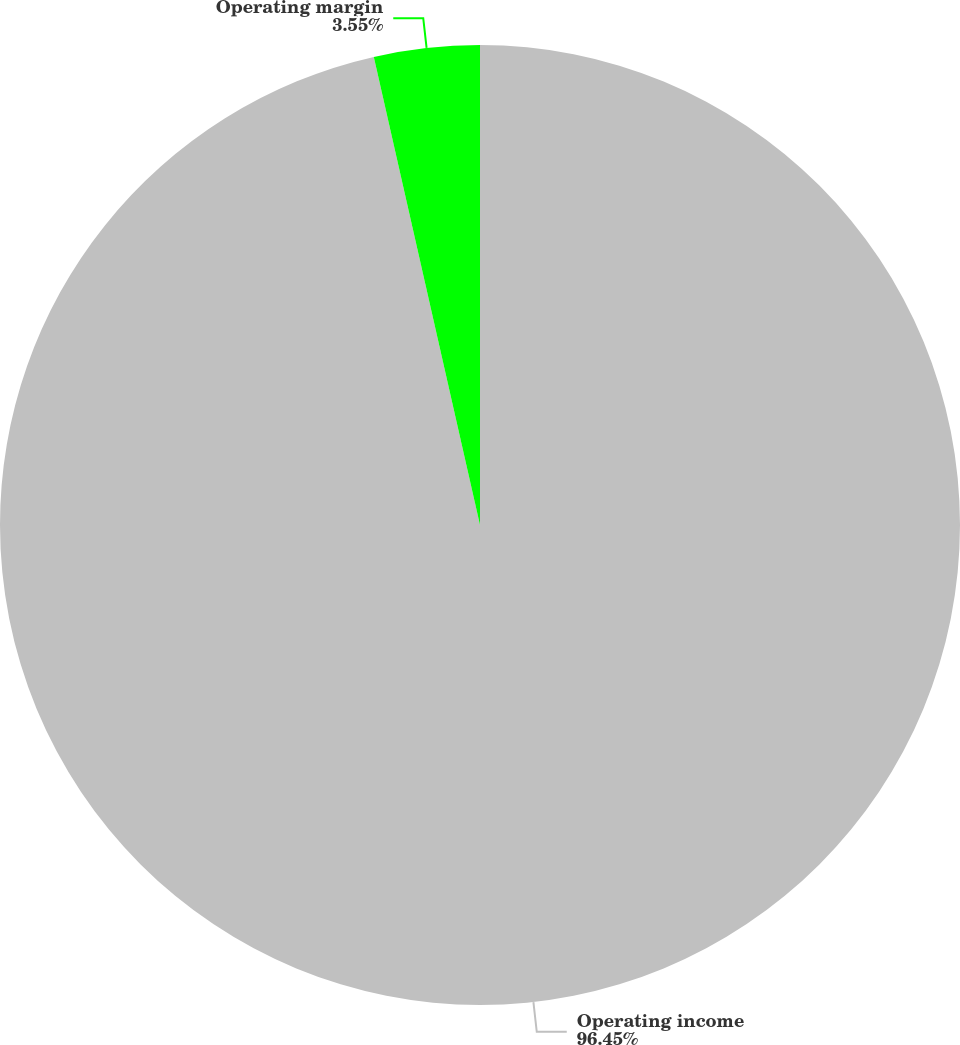Convert chart to OTSL. <chart><loc_0><loc_0><loc_500><loc_500><pie_chart><fcel>Operating income<fcel>Operating margin<nl><fcel>96.45%<fcel>3.55%<nl></chart> 